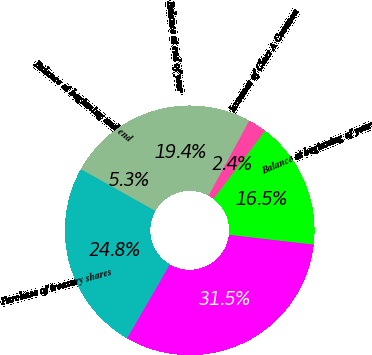<chart> <loc_0><loc_0><loc_500><loc_500><pie_chart><fcel>Balance at beginning of year<fcel>Issuance of Class A Common<fcel>Balance at end of year<fcel>Balance at beginning and end<fcel>Purchase of treasury shares<fcel>Stock-based compensation<nl><fcel>16.53%<fcel>2.41%<fcel>19.44%<fcel>5.32%<fcel>24.8%<fcel>31.51%<nl></chart> 